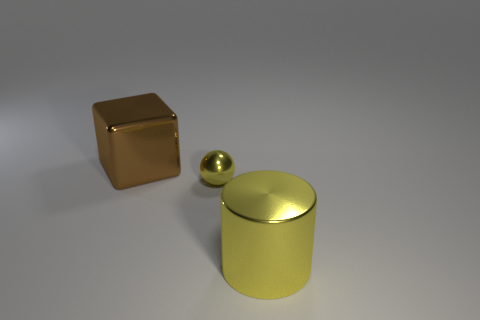Add 3 brown objects. How many objects exist? 6 Subtract all tiny cyan metal objects. Subtract all metal objects. How many objects are left? 0 Add 1 balls. How many balls are left? 2 Add 1 yellow metal cylinders. How many yellow metal cylinders exist? 2 Subtract 0 gray cubes. How many objects are left? 3 Subtract all blocks. How many objects are left? 2 Subtract all gray blocks. Subtract all blue balls. How many blocks are left? 1 